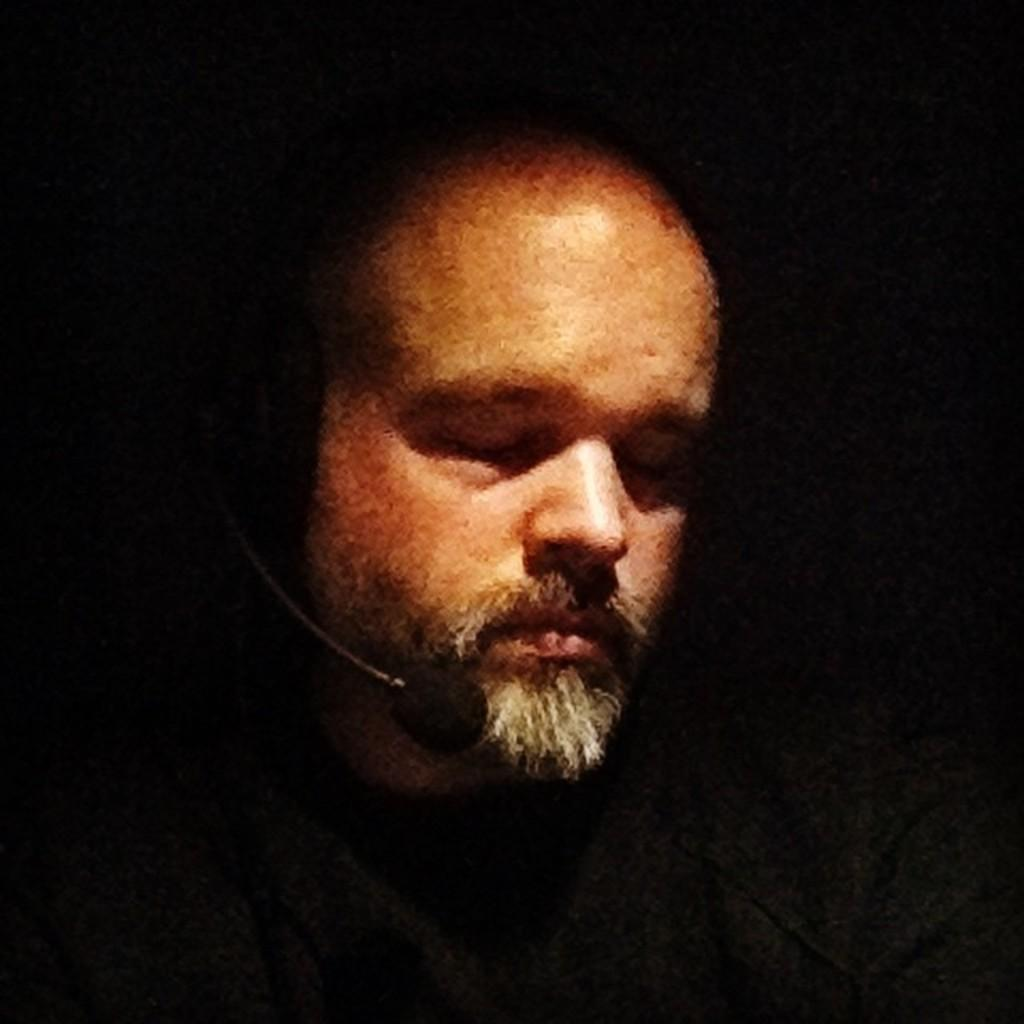What is the main subject of the image? The main subject of the image is a man. What object is visible in the image that is typically used for amplifying sound? There is a mini mic in the image. What type of treatment is the man receiving in the image? There is no indication in the image that the man is receiving any treatment. What kind of zephyr can be seen blowing through the image? There is no zephyr present in the image. 